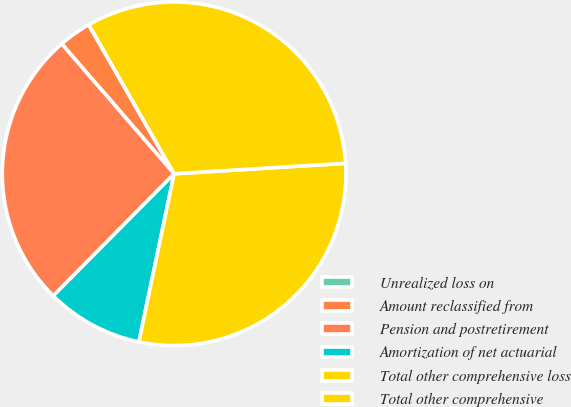Convert chart. <chart><loc_0><loc_0><loc_500><loc_500><pie_chart><fcel>Unrealized loss on<fcel>Amount reclassified from<fcel>Pension and postretirement<fcel>Amortization of net actuarial<fcel>Total other comprehensive loss<fcel>Total other comprehensive<nl><fcel>0.02%<fcel>3.06%<fcel>26.23%<fcel>9.13%<fcel>29.26%<fcel>32.3%<nl></chart> 